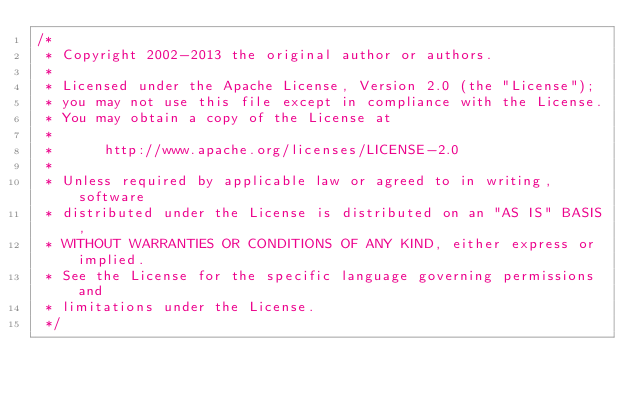Convert code to text. <code><loc_0><loc_0><loc_500><loc_500><_Java_>/*
 * Copyright 2002-2013 the original author or authors.
 *
 * Licensed under the Apache License, Version 2.0 (the "License");
 * you may not use this file except in compliance with the License.
 * You may obtain a copy of the License at
 *
 *      http://www.apache.org/licenses/LICENSE-2.0
 *
 * Unless required by applicable law or agreed to in writing, software
 * distributed under the License is distributed on an "AS IS" BASIS,
 * WITHOUT WARRANTIES OR CONDITIONS OF ANY KIND, either express or implied.
 * See the License for the specific language governing permissions and
 * limitations under the License.
 */
</code> 